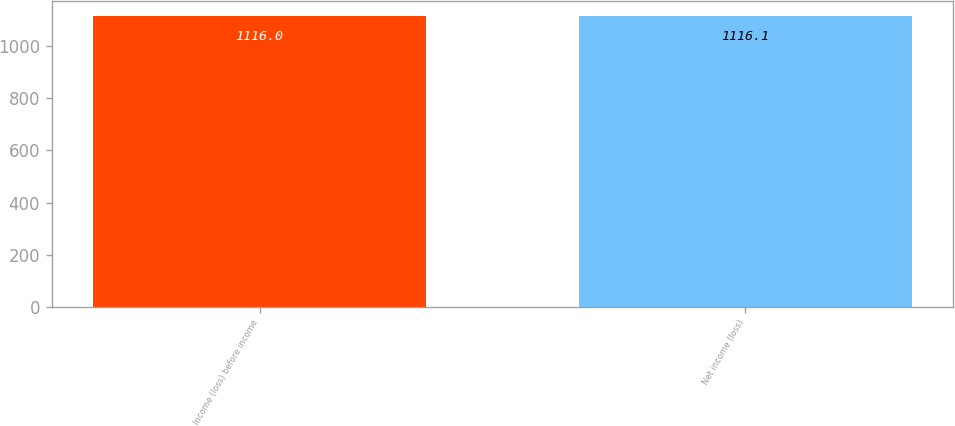<chart> <loc_0><loc_0><loc_500><loc_500><bar_chart><fcel>Income (loss) before income<fcel>Net income (loss)<nl><fcel>1116<fcel>1116.1<nl></chart> 